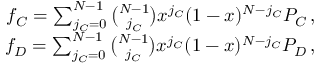Convert formula to latex. <formula><loc_0><loc_0><loc_500><loc_500>\begin{array} { r } { f _ { C } = \sum _ { j _ { C } = 0 } ^ { N - 1 } \binom { N - 1 } { j _ { C } } x ^ { j _ { C } } ( 1 - x ) ^ { N - j _ { C } } P _ { C } \, , } \\ { f _ { D } = \sum _ { j _ { C } = 0 } ^ { N - 1 } \binom { N - 1 } { j _ { C } } x ^ { j _ { C } } ( 1 - x ) ^ { N - j _ { C } } P _ { D } \, , } \end{array}</formula> 